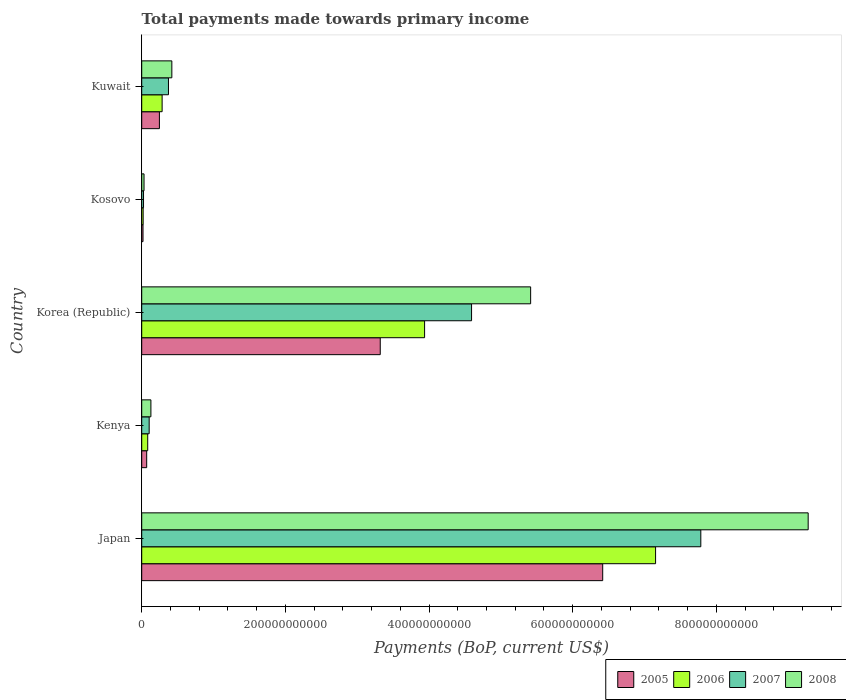How many different coloured bars are there?
Your answer should be very brief. 4. How many groups of bars are there?
Your response must be concise. 5. Are the number of bars per tick equal to the number of legend labels?
Give a very brief answer. Yes. How many bars are there on the 1st tick from the top?
Provide a succinct answer. 4. What is the label of the 1st group of bars from the top?
Your response must be concise. Kuwait. What is the total payments made towards primary income in 2006 in Japan?
Your answer should be compact. 7.15e+11. Across all countries, what is the maximum total payments made towards primary income in 2006?
Your response must be concise. 7.15e+11. Across all countries, what is the minimum total payments made towards primary income in 2006?
Provide a short and direct response. 1.99e+09. In which country was the total payments made towards primary income in 2008 minimum?
Keep it short and to the point. Kosovo. What is the total total payments made towards primary income in 2005 in the graph?
Make the answer very short. 1.01e+12. What is the difference between the total payments made towards primary income in 2007 in Kenya and that in Korea (Republic)?
Offer a terse response. -4.49e+11. What is the difference between the total payments made towards primary income in 2006 in Kenya and the total payments made towards primary income in 2008 in Korea (Republic)?
Offer a very short reply. -5.33e+11. What is the average total payments made towards primary income in 2008 per country?
Keep it short and to the point. 3.05e+11. What is the difference between the total payments made towards primary income in 2008 and total payments made towards primary income in 2005 in Kuwait?
Give a very brief answer. 1.73e+1. What is the ratio of the total payments made towards primary income in 2006 in Kenya to that in Korea (Republic)?
Offer a very short reply. 0.02. Is the difference between the total payments made towards primary income in 2008 in Japan and Korea (Republic) greater than the difference between the total payments made towards primary income in 2005 in Japan and Korea (Republic)?
Provide a succinct answer. Yes. What is the difference between the highest and the second highest total payments made towards primary income in 2006?
Your answer should be compact. 3.22e+11. What is the difference between the highest and the lowest total payments made towards primary income in 2006?
Offer a terse response. 7.13e+11. Is it the case that in every country, the sum of the total payments made towards primary income in 2008 and total payments made towards primary income in 2005 is greater than the sum of total payments made towards primary income in 2007 and total payments made towards primary income in 2006?
Provide a short and direct response. No. How many bars are there?
Offer a very short reply. 20. What is the difference between two consecutive major ticks on the X-axis?
Offer a very short reply. 2.00e+11. Are the values on the major ticks of X-axis written in scientific E-notation?
Your answer should be very brief. No. Does the graph contain any zero values?
Your response must be concise. No. How many legend labels are there?
Provide a short and direct response. 4. What is the title of the graph?
Make the answer very short. Total payments made towards primary income. What is the label or title of the X-axis?
Your response must be concise. Payments (BoP, current US$). What is the Payments (BoP, current US$) of 2005 in Japan?
Give a very brief answer. 6.42e+11. What is the Payments (BoP, current US$) of 2006 in Japan?
Ensure brevity in your answer.  7.15e+11. What is the Payments (BoP, current US$) in 2007 in Japan?
Your answer should be very brief. 7.78e+11. What is the Payments (BoP, current US$) in 2008 in Japan?
Give a very brief answer. 9.28e+11. What is the Payments (BoP, current US$) in 2005 in Kenya?
Provide a succinct answer. 6.92e+09. What is the Payments (BoP, current US$) in 2006 in Kenya?
Give a very brief answer. 8.34e+09. What is the Payments (BoP, current US$) of 2007 in Kenya?
Ensure brevity in your answer.  1.04e+1. What is the Payments (BoP, current US$) in 2008 in Kenya?
Keep it short and to the point. 1.28e+1. What is the Payments (BoP, current US$) in 2005 in Korea (Republic)?
Your answer should be compact. 3.32e+11. What is the Payments (BoP, current US$) in 2006 in Korea (Republic)?
Provide a short and direct response. 3.94e+11. What is the Payments (BoP, current US$) in 2007 in Korea (Republic)?
Provide a short and direct response. 4.59e+11. What is the Payments (BoP, current US$) in 2008 in Korea (Republic)?
Your response must be concise. 5.41e+11. What is the Payments (BoP, current US$) in 2005 in Kosovo?
Make the answer very short. 1.80e+09. What is the Payments (BoP, current US$) in 2006 in Kosovo?
Provide a succinct answer. 1.99e+09. What is the Payments (BoP, current US$) in 2007 in Kosovo?
Give a very brief answer. 2.53e+09. What is the Payments (BoP, current US$) of 2008 in Kosovo?
Offer a terse response. 3.22e+09. What is the Payments (BoP, current US$) of 2005 in Kuwait?
Your answer should be very brief. 2.46e+1. What is the Payments (BoP, current US$) in 2006 in Kuwait?
Make the answer very short. 2.84e+1. What is the Payments (BoP, current US$) in 2007 in Kuwait?
Your response must be concise. 3.72e+1. What is the Payments (BoP, current US$) in 2008 in Kuwait?
Offer a very short reply. 4.19e+1. Across all countries, what is the maximum Payments (BoP, current US$) in 2005?
Your response must be concise. 6.42e+11. Across all countries, what is the maximum Payments (BoP, current US$) of 2006?
Your answer should be compact. 7.15e+11. Across all countries, what is the maximum Payments (BoP, current US$) in 2007?
Make the answer very short. 7.78e+11. Across all countries, what is the maximum Payments (BoP, current US$) of 2008?
Ensure brevity in your answer.  9.28e+11. Across all countries, what is the minimum Payments (BoP, current US$) in 2005?
Keep it short and to the point. 1.80e+09. Across all countries, what is the minimum Payments (BoP, current US$) in 2006?
Your answer should be very brief. 1.99e+09. Across all countries, what is the minimum Payments (BoP, current US$) of 2007?
Offer a terse response. 2.53e+09. Across all countries, what is the minimum Payments (BoP, current US$) in 2008?
Make the answer very short. 3.22e+09. What is the total Payments (BoP, current US$) in 2005 in the graph?
Provide a succinct answer. 1.01e+12. What is the total Payments (BoP, current US$) in 2006 in the graph?
Your response must be concise. 1.15e+12. What is the total Payments (BoP, current US$) of 2007 in the graph?
Give a very brief answer. 1.29e+12. What is the total Payments (BoP, current US$) in 2008 in the graph?
Ensure brevity in your answer.  1.53e+12. What is the difference between the Payments (BoP, current US$) in 2005 in Japan and that in Kenya?
Your answer should be compact. 6.35e+11. What is the difference between the Payments (BoP, current US$) of 2006 in Japan and that in Kenya?
Ensure brevity in your answer.  7.07e+11. What is the difference between the Payments (BoP, current US$) in 2007 in Japan and that in Kenya?
Ensure brevity in your answer.  7.68e+11. What is the difference between the Payments (BoP, current US$) of 2008 in Japan and that in Kenya?
Offer a terse response. 9.15e+11. What is the difference between the Payments (BoP, current US$) of 2005 in Japan and that in Korea (Republic)?
Give a very brief answer. 3.10e+11. What is the difference between the Payments (BoP, current US$) of 2006 in Japan and that in Korea (Republic)?
Provide a short and direct response. 3.22e+11. What is the difference between the Payments (BoP, current US$) in 2007 in Japan and that in Korea (Republic)?
Your response must be concise. 3.19e+11. What is the difference between the Payments (BoP, current US$) in 2008 in Japan and that in Korea (Republic)?
Offer a very short reply. 3.86e+11. What is the difference between the Payments (BoP, current US$) of 2005 in Japan and that in Kosovo?
Your answer should be compact. 6.40e+11. What is the difference between the Payments (BoP, current US$) in 2006 in Japan and that in Kosovo?
Offer a very short reply. 7.13e+11. What is the difference between the Payments (BoP, current US$) of 2007 in Japan and that in Kosovo?
Offer a terse response. 7.76e+11. What is the difference between the Payments (BoP, current US$) in 2008 in Japan and that in Kosovo?
Keep it short and to the point. 9.25e+11. What is the difference between the Payments (BoP, current US$) in 2005 in Japan and that in Kuwait?
Ensure brevity in your answer.  6.17e+11. What is the difference between the Payments (BoP, current US$) in 2006 in Japan and that in Kuwait?
Provide a short and direct response. 6.87e+11. What is the difference between the Payments (BoP, current US$) in 2007 in Japan and that in Kuwait?
Provide a short and direct response. 7.41e+11. What is the difference between the Payments (BoP, current US$) of 2008 in Japan and that in Kuwait?
Keep it short and to the point. 8.86e+11. What is the difference between the Payments (BoP, current US$) in 2005 in Kenya and that in Korea (Republic)?
Make the answer very short. -3.25e+11. What is the difference between the Payments (BoP, current US$) of 2006 in Kenya and that in Korea (Republic)?
Your answer should be very brief. -3.85e+11. What is the difference between the Payments (BoP, current US$) in 2007 in Kenya and that in Korea (Republic)?
Offer a terse response. -4.49e+11. What is the difference between the Payments (BoP, current US$) of 2008 in Kenya and that in Korea (Republic)?
Offer a very short reply. -5.29e+11. What is the difference between the Payments (BoP, current US$) in 2005 in Kenya and that in Kosovo?
Your answer should be very brief. 5.12e+09. What is the difference between the Payments (BoP, current US$) of 2006 in Kenya and that in Kosovo?
Offer a terse response. 6.35e+09. What is the difference between the Payments (BoP, current US$) of 2007 in Kenya and that in Kosovo?
Offer a terse response. 7.84e+09. What is the difference between the Payments (BoP, current US$) of 2008 in Kenya and that in Kosovo?
Your answer should be compact. 9.56e+09. What is the difference between the Payments (BoP, current US$) of 2005 in Kenya and that in Kuwait?
Offer a very short reply. -1.77e+1. What is the difference between the Payments (BoP, current US$) in 2006 in Kenya and that in Kuwait?
Make the answer very short. -2.01e+1. What is the difference between the Payments (BoP, current US$) of 2007 in Kenya and that in Kuwait?
Provide a short and direct response. -2.69e+1. What is the difference between the Payments (BoP, current US$) in 2008 in Kenya and that in Kuwait?
Ensure brevity in your answer.  -2.92e+1. What is the difference between the Payments (BoP, current US$) in 2005 in Korea (Republic) and that in Kosovo?
Keep it short and to the point. 3.30e+11. What is the difference between the Payments (BoP, current US$) of 2006 in Korea (Republic) and that in Kosovo?
Give a very brief answer. 3.92e+11. What is the difference between the Payments (BoP, current US$) of 2007 in Korea (Republic) and that in Kosovo?
Keep it short and to the point. 4.57e+11. What is the difference between the Payments (BoP, current US$) in 2008 in Korea (Republic) and that in Kosovo?
Offer a terse response. 5.38e+11. What is the difference between the Payments (BoP, current US$) in 2005 in Korea (Republic) and that in Kuwait?
Keep it short and to the point. 3.07e+11. What is the difference between the Payments (BoP, current US$) of 2006 in Korea (Republic) and that in Kuwait?
Ensure brevity in your answer.  3.65e+11. What is the difference between the Payments (BoP, current US$) of 2007 in Korea (Republic) and that in Kuwait?
Your answer should be compact. 4.22e+11. What is the difference between the Payments (BoP, current US$) in 2008 in Korea (Republic) and that in Kuwait?
Offer a very short reply. 5.00e+11. What is the difference between the Payments (BoP, current US$) in 2005 in Kosovo and that in Kuwait?
Give a very brief answer. -2.28e+1. What is the difference between the Payments (BoP, current US$) of 2006 in Kosovo and that in Kuwait?
Provide a succinct answer. -2.64e+1. What is the difference between the Payments (BoP, current US$) in 2007 in Kosovo and that in Kuwait?
Give a very brief answer. -3.47e+1. What is the difference between the Payments (BoP, current US$) of 2008 in Kosovo and that in Kuwait?
Keep it short and to the point. -3.87e+1. What is the difference between the Payments (BoP, current US$) in 2005 in Japan and the Payments (BoP, current US$) in 2006 in Kenya?
Make the answer very short. 6.33e+11. What is the difference between the Payments (BoP, current US$) of 2005 in Japan and the Payments (BoP, current US$) of 2007 in Kenya?
Your answer should be very brief. 6.31e+11. What is the difference between the Payments (BoP, current US$) in 2005 in Japan and the Payments (BoP, current US$) in 2008 in Kenya?
Provide a short and direct response. 6.29e+11. What is the difference between the Payments (BoP, current US$) of 2006 in Japan and the Payments (BoP, current US$) of 2007 in Kenya?
Offer a very short reply. 7.05e+11. What is the difference between the Payments (BoP, current US$) in 2006 in Japan and the Payments (BoP, current US$) in 2008 in Kenya?
Offer a terse response. 7.03e+11. What is the difference between the Payments (BoP, current US$) of 2007 in Japan and the Payments (BoP, current US$) of 2008 in Kenya?
Your answer should be compact. 7.66e+11. What is the difference between the Payments (BoP, current US$) of 2005 in Japan and the Payments (BoP, current US$) of 2006 in Korea (Republic)?
Ensure brevity in your answer.  2.48e+11. What is the difference between the Payments (BoP, current US$) in 2005 in Japan and the Payments (BoP, current US$) in 2007 in Korea (Republic)?
Provide a succinct answer. 1.83e+11. What is the difference between the Payments (BoP, current US$) in 2005 in Japan and the Payments (BoP, current US$) in 2008 in Korea (Republic)?
Make the answer very short. 1.00e+11. What is the difference between the Payments (BoP, current US$) in 2006 in Japan and the Payments (BoP, current US$) in 2007 in Korea (Republic)?
Provide a succinct answer. 2.56e+11. What is the difference between the Payments (BoP, current US$) in 2006 in Japan and the Payments (BoP, current US$) in 2008 in Korea (Republic)?
Provide a short and direct response. 1.74e+11. What is the difference between the Payments (BoP, current US$) of 2007 in Japan and the Payments (BoP, current US$) of 2008 in Korea (Republic)?
Ensure brevity in your answer.  2.37e+11. What is the difference between the Payments (BoP, current US$) in 2005 in Japan and the Payments (BoP, current US$) in 2006 in Kosovo?
Offer a terse response. 6.40e+11. What is the difference between the Payments (BoP, current US$) of 2005 in Japan and the Payments (BoP, current US$) of 2007 in Kosovo?
Provide a succinct answer. 6.39e+11. What is the difference between the Payments (BoP, current US$) in 2005 in Japan and the Payments (BoP, current US$) in 2008 in Kosovo?
Keep it short and to the point. 6.39e+11. What is the difference between the Payments (BoP, current US$) of 2006 in Japan and the Payments (BoP, current US$) of 2007 in Kosovo?
Your answer should be very brief. 7.13e+11. What is the difference between the Payments (BoP, current US$) in 2006 in Japan and the Payments (BoP, current US$) in 2008 in Kosovo?
Your answer should be compact. 7.12e+11. What is the difference between the Payments (BoP, current US$) in 2007 in Japan and the Payments (BoP, current US$) in 2008 in Kosovo?
Make the answer very short. 7.75e+11. What is the difference between the Payments (BoP, current US$) in 2005 in Japan and the Payments (BoP, current US$) in 2006 in Kuwait?
Ensure brevity in your answer.  6.13e+11. What is the difference between the Payments (BoP, current US$) in 2005 in Japan and the Payments (BoP, current US$) in 2007 in Kuwait?
Your answer should be very brief. 6.05e+11. What is the difference between the Payments (BoP, current US$) in 2005 in Japan and the Payments (BoP, current US$) in 2008 in Kuwait?
Offer a very short reply. 6.00e+11. What is the difference between the Payments (BoP, current US$) of 2006 in Japan and the Payments (BoP, current US$) of 2007 in Kuwait?
Your answer should be compact. 6.78e+11. What is the difference between the Payments (BoP, current US$) in 2006 in Japan and the Payments (BoP, current US$) in 2008 in Kuwait?
Offer a terse response. 6.73e+11. What is the difference between the Payments (BoP, current US$) in 2007 in Japan and the Payments (BoP, current US$) in 2008 in Kuwait?
Your response must be concise. 7.36e+11. What is the difference between the Payments (BoP, current US$) in 2005 in Kenya and the Payments (BoP, current US$) in 2006 in Korea (Republic)?
Provide a succinct answer. -3.87e+11. What is the difference between the Payments (BoP, current US$) of 2005 in Kenya and the Payments (BoP, current US$) of 2007 in Korea (Republic)?
Your answer should be compact. -4.52e+11. What is the difference between the Payments (BoP, current US$) of 2005 in Kenya and the Payments (BoP, current US$) of 2008 in Korea (Republic)?
Provide a succinct answer. -5.35e+11. What is the difference between the Payments (BoP, current US$) in 2006 in Kenya and the Payments (BoP, current US$) in 2007 in Korea (Republic)?
Keep it short and to the point. -4.51e+11. What is the difference between the Payments (BoP, current US$) of 2006 in Kenya and the Payments (BoP, current US$) of 2008 in Korea (Republic)?
Your answer should be very brief. -5.33e+11. What is the difference between the Payments (BoP, current US$) of 2007 in Kenya and the Payments (BoP, current US$) of 2008 in Korea (Republic)?
Make the answer very short. -5.31e+11. What is the difference between the Payments (BoP, current US$) in 2005 in Kenya and the Payments (BoP, current US$) in 2006 in Kosovo?
Give a very brief answer. 4.93e+09. What is the difference between the Payments (BoP, current US$) in 2005 in Kenya and the Payments (BoP, current US$) in 2007 in Kosovo?
Ensure brevity in your answer.  4.39e+09. What is the difference between the Payments (BoP, current US$) in 2005 in Kenya and the Payments (BoP, current US$) in 2008 in Kosovo?
Give a very brief answer. 3.70e+09. What is the difference between the Payments (BoP, current US$) of 2006 in Kenya and the Payments (BoP, current US$) of 2007 in Kosovo?
Ensure brevity in your answer.  5.81e+09. What is the difference between the Payments (BoP, current US$) in 2006 in Kenya and the Payments (BoP, current US$) in 2008 in Kosovo?
Give a very brief answer. 5.12e+09. What is the difference between the Payments (BoP, current US$) in 2007 in Kenya and the Payments (BoP, current US$) in 2008 in Kosovo?
Offer a terse response. 7.14e+09. What is the difference between the Payments (BoP, current US$) in 2005 in Kenya and the Payments (BoP, current US$) in 2006 in Kuwait?
Make the answer very short. -2.15e+1. What is the difference between the Payments (BoP, current US$) in 2005 in Kenya and the Payments (BoP, current US$) in 2007 in Kuwait?
Provide a short and direct response. -3.03e+1. What is the difference between the Payments (BoP, current US$) of 2005 in Kenya and the Payments (BoP, current US$) of 2008 in Kuwait?
Your answer should be very brief. -3.50e+1. What is the difference between the Payments (BoP, current US$) of 2006 in Kenya and the Payments (BoP, current US$) of 2007 in Kuwait?
Provide a short and direct response. -2.89e+1. What is the difference between the Payments (BoP, current US$) of 2006 in Kenya and the Payments (BoP, current US$) of 2008 in Kuwait?
Your response must be concise. -3.36e+1. What is the difference between the Payments (BoP, current US$) in 2007 in Kenya and the Payments (BoP, current US$) in 2008 in Kuwait?
Make the answer very short. -3.16e+1. What is the difference between the Payments (BoP, current US$) of 2005 in Korea (Republic) and the Payments (BoP, current US$) of 2006 in Kosovo?
Keep it short and to the point. 3.30e+11. What is the difference between the Payments (BoP, current US$) of 2005 in Korea (Republic) and the Payments (BoP, current US$) of 2007 in Kosovo?
Ensure brevity in your answer.  3.30e+11. What is the difference between the Payments (BoP, current US$) in 2005 in Korea (Republic) and the Payments (BoP, current US$) in 2008 in Kosovo?
Give a very brief answer. 3.29e+11. What is the difference between the Payments (BoP, current US$) in 2006 in Korea (Republic) and the Payments (BoP, current US$) in 2007 in Kosovo?
Your answer should be very brief. 3.91e+11. What is the difference between the Payments (BoP, current US$) in 2006 in Korea (Republic) and the Payments (BoP, current US$) in 2008 in Kosovo?
Ensure brevity in your answer.  3.91e+11. What is the difference between the Payments (BoP, current US$) of 2007 in Korea (Republic) and the Payments (BoP, current US$) of 2008 in Kosovo?
Ensure brevity in your answer.  4.56e+11. What is the difference between the Payments (BoP, current US$) of 2005 in Korea (Republic) and the Payments (BoP, current US$) of 2006 in Kuwait?
Offer a very short reply. 3.04e+11. What is the difference between the Payments (BoP, current US$) of 2005 in Korea (Republic) and the Payments (BoP, current US$) of 2007 in Kuwait?
Provide a short and direct response. 2.95e+11. What is the difference between the Payments (BoP, current US$) in 2005 in Korea (Republic) and the Payments (BoP, current US$) in 2008 in Kuwait?
Offer a terse response. 2.90e+11. What is the difference between the Payments (BoP, current US$) of 2006 in Korea (Republic) and the Payments (BoP, current US$) of 2007 in Kuwait?
Provide a short and direct response. 3.57e+11. What is the difference between the Payments (BoP, current US$) of 2006 in Korea (Republic) and the Payments (BoP, current US$) of 2008 in Kuwait?
Give a very brief answer. 3.52e+11. What is the difference between the Payments (BoP, current US$) in 2007 in Korea (Republic) and the Payments (BoP, current US$) in 2008 in Kuwait?
Your response must be concise. 4.17e+11. What is the difference between the Payments (BoP, current US$) in 2005 in Kosovo and the Payments (BoP, current US$) in 2006 in Kuwait?
Your answer should be very brief. -2.66e+1. What is the difference between the Payments (BoP, current US$) of 2005 in Kosovo and the Payments (BoP, current US$) of 2007 in Kuwait?
Give a very brief answer. -3.54e+1. What is the difference between the Payments (BoP, current US$) in 2005 in Kosovo and the Payments (BoP, current US$) in 2008 in Kuwait?
Your answer should be compact. -4.01e+1. What is the difference between the Payments (BoP, current US$) in 2006 in Kosovo and the Payments (BoP, current US$) in 2007 in Kuwait?
Your answer should be compact. -3.53e+1. What is the difference between the Payments (BoP, current US$) in 2006 in Kosovo and the Payments (BoP, current US$) in 2008 in Kuwait?
Offer a terse response. -3.99e+1. What is the difference between the Payments (BoP, current US$) of 2007 in Kosovo and the Payments (BoP, current US$) of 2008 in Kuwait?
Your response must be concise. -3.94e+1. What is the average Payments (BoP, current US$) of 2005 per country?
Make the answer very short. 2.01e+11. What is the average Payments (BoP, current US$) of 2006 per country?
Ensure brevity in your answer.  2.30e+11. What is the average Payments (BoP, current US$) of 2007 per country?
Offer a terse response. 2.58e+11. What is the average Payments (BoP, current US$) of 2008 per country?
Provide a short and direct response. 3.05e+11. What is the difference between the Payments (BoP, current US$) of 2005 and Payments (BoP, current US$) of 2006 in Japan?
Your response must be concise. -7.36e+1. What is the difference between the Payments (BoP, current US$) in 2005 and Payments (BoP, current US$) in 2007 in Japan?
Keep it short and to the point. -1.37e+11. What is the difference between the Payments (BoP, current US$) in 2005 and Payments (BoP, current US$) in 2008 in Japan?
Provide a short and direct response. -2.86e+11. What is the difference between the Payments (BoP, current US$) of 2006 and Payments (BoP, current US$) of 2007 in Japan?
Ensure brevity in your answer.  -6.30e+1. What is the difference between the Payments (BoP, current US$) of 2006 and Payments (BoP, current US$) of 2008 in Japan?
Keep it short and to the point. -2.12e+11. What is the difference between the Payments (BoP, current US$) of 2007 and Payments (BoP, current US$) of 2008 in Japan?
Offer a very short reply. -1.49e+11. What is the difference between the Payments (BoP, current US$) in 2005 and Payments (BoP, current US$) in 2006 in Kenya?
Provide a succinct answer. -1.42e+09. What is the difference between the Payments (BoP, current US$) of 2005 and Payments (BoP, current US$) of 2007 in Kenya?
Provide a short and direct response. -3.44e+09. What is the difference between the Payments (BoP, current US$) in 2005 and Payments (BoP, current US$) in 2008 in Kenya?
Your response must be concise. -5.86e+09. What is the difference between the Payments (BoP, current US$) of 2006 and Payments (BoP, current US$) of 2007 in Kenya?
Offer a terse response. -2.02e+09. What is the difference between the Payments (BoP, current US$) in 2006 and Payments (BoP, current US$) in 2008 in Kenya?
Your answer should be very brief. -4.44e+09. What is the difference between the Payments (BoP, current US$) in 2007 and Payments (BoP, current US$) in 2008 in Kenya?
Provide a succinct answer. -2.42e+09. What is the difference between the Payments (BoP, current US$) of 2005 and Payments (BoP, current US$) of 2006 in Korea (Republic)?
Offer a terse response. -6.17e+1. What is the difference between the Payments (BoP, current US$) in 2005 and Payments (BoP, current US$) in 2007 in Korea (Republic)?
Offer a terse response. -1.27e+11. What is the difference between the Payments (BoP, current US$) in 2005 and Payments (BoP, current US$) in 2008 in Korea (Republic)?
Ensure brevity in your answer.  -2.09e+11. What is the difference between the Payments (BoP, current US$) of 2006 and Payments (BoP, current US$) of 2007 in Korea (Republic)?
Your response must be concise. -6.54e+1. What is the difference between the Payments (BoP, current US$) of 2006 and Payments (BoP, current US$) of 2008 in Korea (Republic)?
Your response must be concise. -1.48e+11. What is the difference between the Payments (BoP, current US$) in 2007 and Payments (BoP, current US$) in 2008 in Korea (Republic)?
Ensure brevity in your answer.  -8.22e+1. What is the difference between the Payments (BoP, current US$) in 2005 and Payments (BoP, current US$) in 2006 in Kosovo?
Make the answer very short. -1.83e+08. What is the difference between the Payments (BoP, current US$) in 2005 and Payments (BoP, current US$) in 2007 in Kosovo?
Give a very brief answer. -7.24e+08. What is the difference between the Payments (BoP, current US$) in 2005 and Payments (BoP, current US$) in 2008 in Kosovo?
Offer a very short reply. -1.42e+09. What is the difference between the Payments (BoP, current US$) of 2006 and Payments (BoP, current US$) of 2007 in Kosovo?
Provide a succinct answer. -5.41e+08. What is the difference between the Payments (BoP, current US$) of 2006 and Payments (BoP, current US$) of 2008 in Kosovo?
Your response must be concise. -1.24e+09. What is the difference between the Payments (BoP, current US$) of 2007 and Payments (BoP, current US$) of 2008 in Kosovo?
Ensure brevity in your answer.  -6.94e+08. What is the difference between the Payments (BoP, current US$) in 2005 and Payments (BoP, current US$) in 2006 in Kuwait?
Give a very brief answer. -3.80e+09. What is the difference between the Payments (BoP, current US$) of 2005 and Payments (BoP, current US$) of 2007 in Kuwait?
Your answer should be compact. -1.26e+1. What is the difference between the Payments (BoP, current US$) in 2005 and Payments (BoP, current US$) in 2008 in Kuwait?
Provide a short and direct response. -1.73e+1. What is the difference between the Payments (BoP, current US$) of 2006 and Payments (BoP, current US$) of 2007 in Kuwait?
Make the answer very short. -8.83e+09. What is the difference between the Payments (BoP, current US$) of 2006 and Payments (BoP, current US$) of 2008 in Kuwait?
Offer a very short reply. -1.35e+1. What is the difference between the Payments (BoP, current US$) of 2007 and Payments (BoP, current US$) of 2008 in Kuwait?
Ensure brevity in your answer.  -4.70e+09. What is the ratio of the Payments (BoP, current US$) of 2005 in Japan to that in Kenya?
Give a very brief answer. 92.74. What is the ratio of the Payments (BoP, current US$) in 2006 in Japan to that in Kenya?
Give a very brief answer. 85.77. What is the ratio of the Payments (BoP, current US$) of 2007 in Japan to that in Kenya?
Your answer should be compact. 75.11. What is the ratio of the Payments (BoP, current US$) of 2008 in Japan to that in Kenya?
Give a very brief answer. 72.6. What is the ratio of the Payments (BoP, current US$) in 2005 in Japan to that in Korea (Republic)?
Your answer should be compact. 1.93. What is the ratio of the Payments (BoP, current US$) in 2006 in Japan to that in Korea (Republic)?
Your answer should be very brief. 1.82. What is the ratio of the Payments (BoP, current US$) in 2007 in Japan to that in Korea (Republic)?
Offer a terse response. 1.7. What is the ratio of the Payments (BoP, current US$) of 2008 in Japan to that in Korea (Republic)?
Ensure brevity in your answer.  1.71. What is the ratio of the Payments (BoP, current US$) of 2005 in Japan to that in Kosovo?
Make the answer very short. 355.86. What is the ratio of the Payments (BoP, current US$) of 2006 in Japan to that in Kosovo?
Offer a very short reply. 360.13. What is the ratio of the Payments (BoP, current US$) of 2007 in Japan to that in Kosovo?
Make the answer very short. 307.92. What is the ratio of the Payments (BoP, current US$) of 2008 in Japan to that in Kosovo?
Make the answer very short. 287.94. What is the ratio of the Payments (BoP, current US$) of 2005 in Japan to that in Kuwait?
Offer a terse response. 26.08. What is the ratio of the Payments (BoP, current US$) of 2006 in Japan to that in Kuwait?
Give a very brief answer. 25.18. What is the ratio of the Payments (BoP, current US$) of 2007 in Japan to that in Kuwait?
Your answer should be compact. 20.9. What is the ratio of the Payments (BoP, current US$) in 2008 in Japan to that in Kuwait?
Offer a terse response. 22.13. What is the ratio of the Payments (BoP, current US$) of 2005 in Kenya to that in Korea (Republic)?
Your answer should be very brief. 0.02. What is the ratio of the Payments (BoP, current US$) of 2006 in Kenya to that in Korea (Republic)?
Your response must be concise. 0.02. What is the ratio of the Payments (BoP, current US$) in 2007 in Kenya to that in Korea (Republic)?
Keep it short and to the point. 0.02. What is the ratio of the Payments (BoP, current US$) of 2008 in Kenya to that in Korea (Republic)?
Make the answer very short. 0.02. What is the ratio of the Payments (BoP, current US$) in 2005 in Kenya to that in Kosovo?
Your response must be concise. 3.84. What is the ratio of the Payments (BoP, current US$) of 2006 in Kenya to that in Kosovo?
Keep it short and to the point. 4.2. What is the ratio of the Payments (BoP, current US$) in 2007 in Kenya to that in Kosovo?
Ensure brevity in your answer.  4.1. What is the ratio of the Payments (BoP, current US$) in 2008 in Kenya to that in Kosovo?
Your response must be concise. 3.97. What is the ratio of the Payments (BoP, current US$) of 2005 in Kenya to that in Kuwait?
Offer a terse response. 0.28. What is the ratio of the Payments (BoP, current US$) of 2006 in Kenya to that in Kuwait?
Make the answer very short. 0.29. What is the ratio of the Payments (BoP, current US$) in 2007 in Kenya to that in Kuwait?
Offer a very short reply. 0.28. What is the ratio of the Payments (BoP, current US$) in 2008 in Kenya to that in Kuwait?
Make the answer very short. 0.3. What is the ratio of the Payments (BoP, current US$) in 2005 in Korea (Republic) to that in Kosovo?
Make the answer very short. 184.13. What is the ratio of the Payments (BoP, current US$) in 2006 in Korea (Republic) to that in Kosovo?
Your response must be concise. 198.25. What is the ratio of the Payments (BoP, current US$) of 2007 in Korea (Republic) to that in Kosovo?
Your response must be concise. 181.66. What is the ratio of the Payments (BoP, current US$) of 2008 in Korea (Republic) to that in Kosovo?
Your answer should be very brief. 168.03. What is the ratio of the Payments (BoP, current US$) of 2005 in Korea (Republic) to that in Kuwait?
Provide a short and direct response. 13.49. What is the ratio of the Payments (BoP, current US$) in 2006 in Korea (Republic) to that in Kuwait?
Give a very brief answer. 13.86. What is the ratio of the Payments (BoP, current US$) of 2007 in Korea (Republic) to that in Kuwait?
Keep it short and to the point. 12.33. What is the ratio of the Payments (BoP, current US$) of 2008 in Korea (Republic) to that in Kuwait?
Your response must be concise. 12.91. What is the ratio of the Payments (BoP, current US$) in 2005 in Kosovo to that in Kuwait?
Provide a succinct answer. 0.07. What is the ratio of the Payments (BoP, current US$) of 2006 in Kosovo to that in Kuwait?
Your answer should be very brief. 0.07. What is the ratio of the Payments (BoP, current US$) of 2007 in Kosovo to that in Kuwait?
Your answer should be compact. 0.07. What is the ratio of the Payments (BoP, current US$) in 2008 in Kosovo to that in Kuwait?
Ensure brevity in your answer.  0.08. What is the difference between the highest and the second highest Payments (BoP, current US$) of 2005?
Your answer should be compact. 3.10e+11. What is the difference between the highest and the second highest Payments (BoP, current US$) of 2006?
Provide a succinct answer. 3.22e+11. What is the difference between the highest and the second highest Payments (BoP, current US$) of 2007?
Your response must be concise. 3.19e+11. What is the difference between the highest and the second highest Payments (BoP, current US$) in 2008?
Keep it short and to the point. 3.86e+11. What is the difference between the highest and the lowest Payments (BoP, current US$) of 2005?
Give a very brief answer. 6.40e+11. What is the difference between the highest and the lowest Payments (BoP, current US$) of 2006?
Provide a short and direct response. 7.13e+11. What is the difference between the highest and the lowest Payments (BoP, current US$) in 2007?
Provide a short and direct response. 7.76e+11. What is the difference between the highest and the lowest Payments (BoP, current US$) of 2008?
Provide a succinct answer. 9.25e+11. 